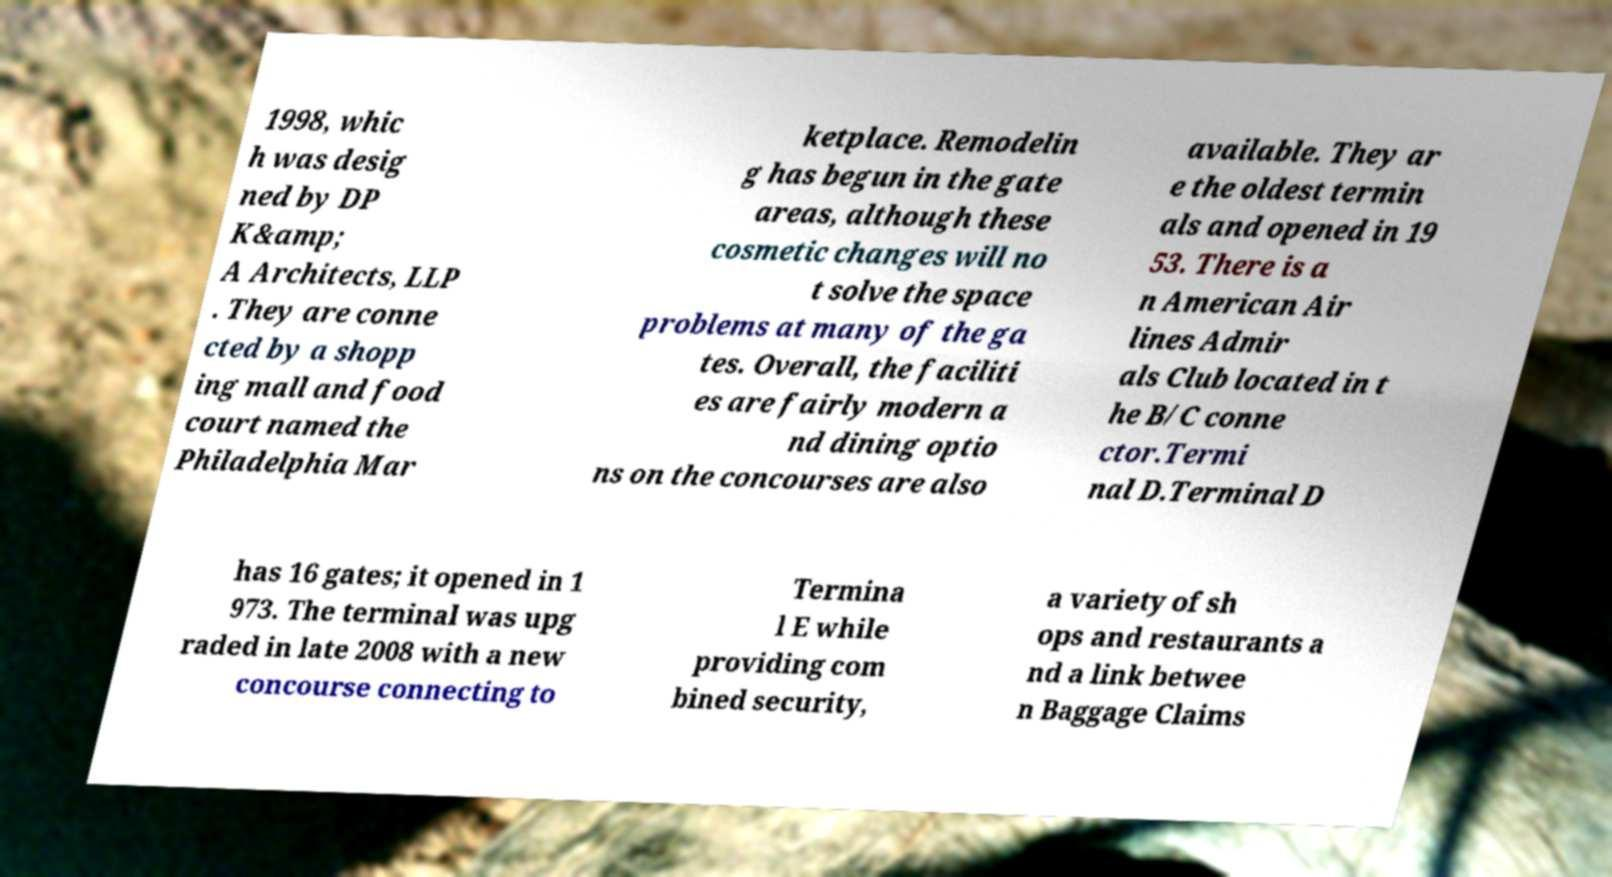Can you accurately transcribe the text from the provided image for me? 1998, whic h was desig ned by DP K&amp; A Architects, LLP . They are conne cted by a shopp ing mall and food court named the Philadelphia Mar ketplace. Remodelin g has begun in the gate areas, although these cosmetic changes will no t solve the space problems at many of the ga tes. Overall, the faciliti es are fairly modern a nd dining optio ns on the concourses are also available. They ar e the oldest termin als and opened in 19 53. There is a n American Air lines Admir als Club located in t he B/C conne ctor.Termi nal D.Terminal D has 16 gates; it opened in 1 973. The terminal was upg raded in late 2008 with a new concourse connecting to Termina l E while providing com bined security, a variety of sh ops and restaurants a nd a link betwee n Baggage Claims 